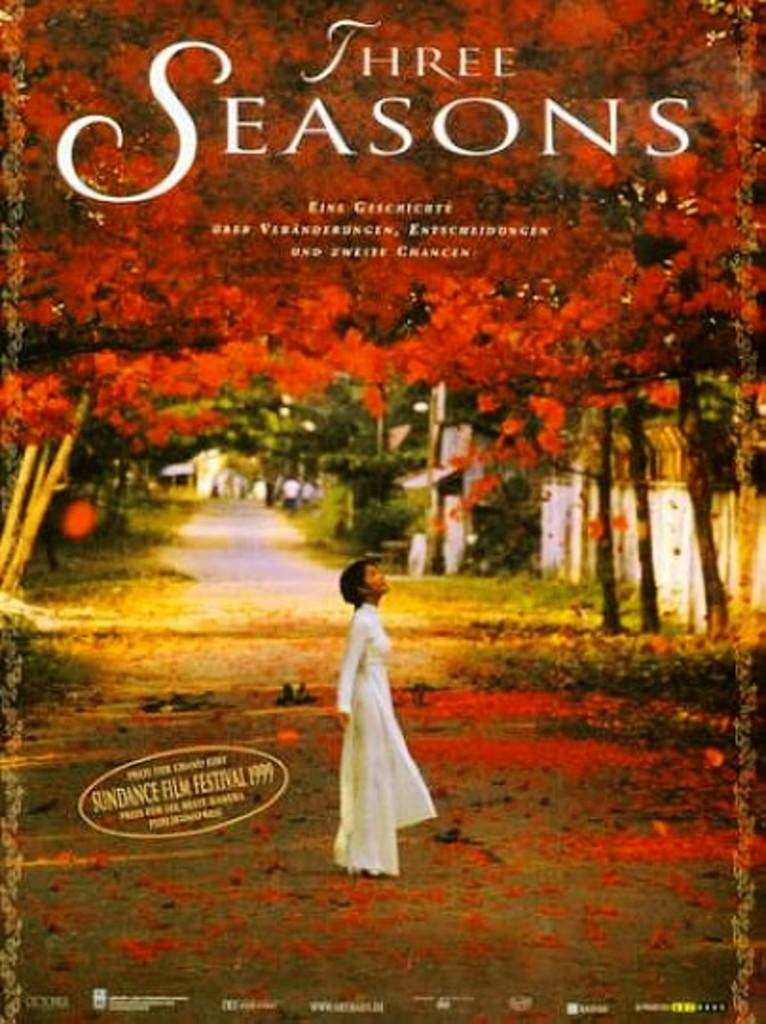<image>
Describe the image concisely. Three Seasons from the Sundance Fall Festival 1999. 